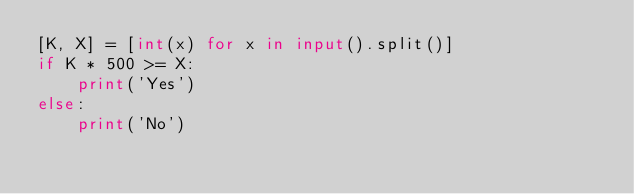Convert code to text. <code><loc_0><loc_0><loc_500><loc_500><_Python_>[K, X] = [int(x) for x in input().split()]
if K * 500 >= X:
    print('Yes')
else:
    print('No')</code> 